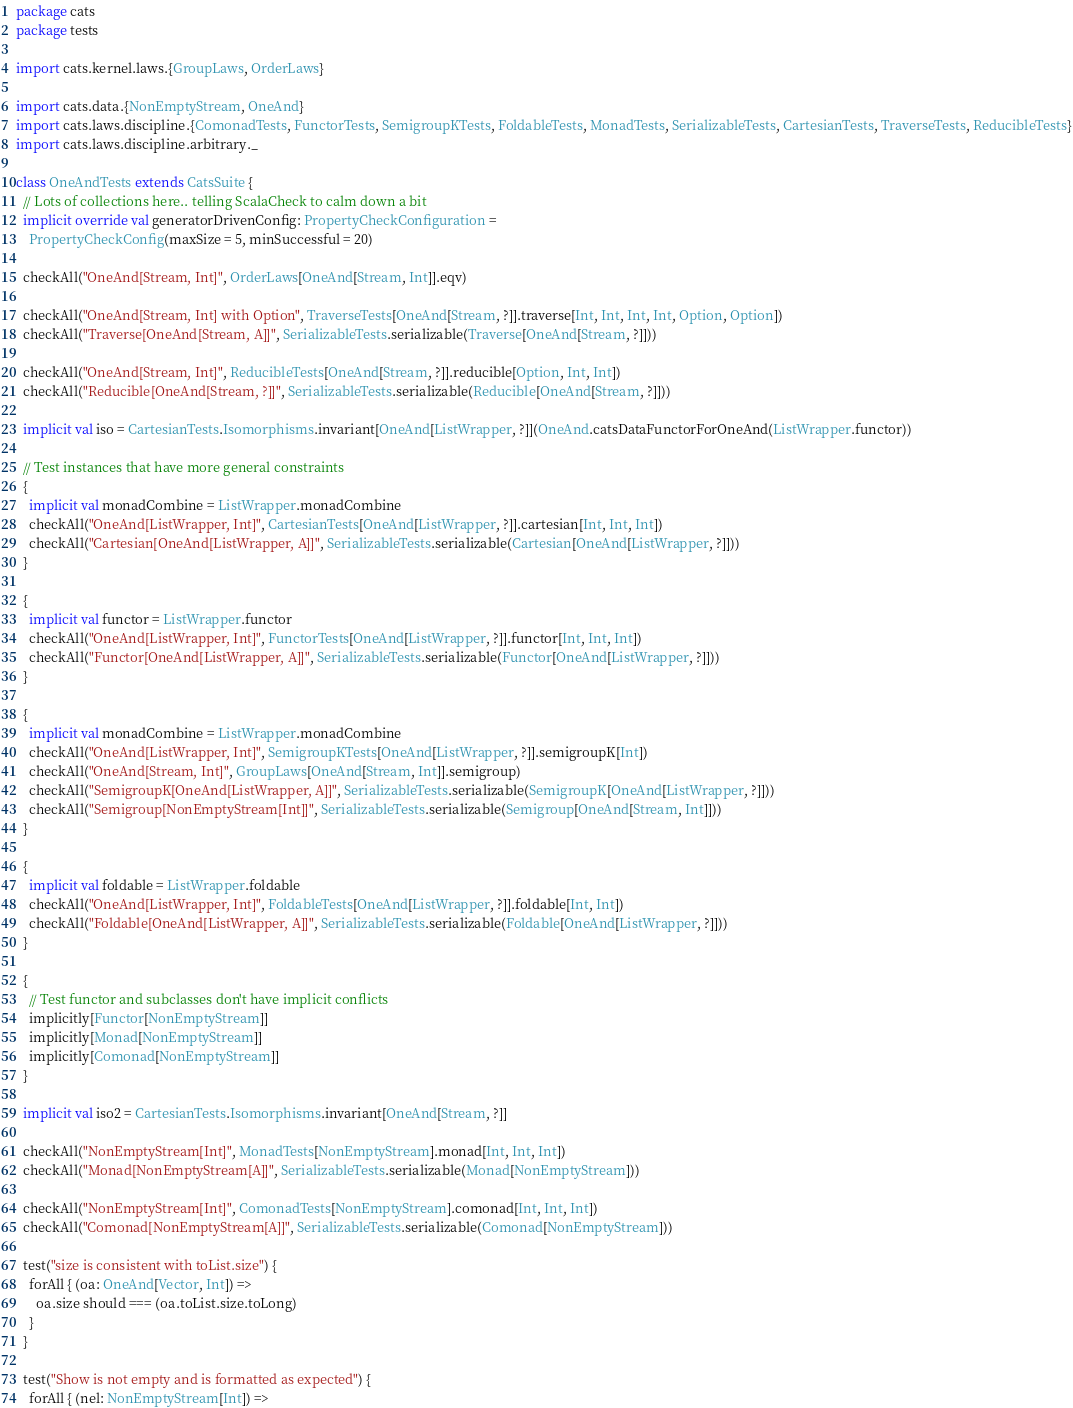Convert code to text. <code><loc_0><loc_0><loc_500><loc_500><_Scala_>package cats
package tests

import cats.kernel.laws.{GroupLaws, OrderLaws}

import cats.data.{NonEmptyStream, OneAnd}
import cats.laws.discipline.{ComonadTests, FunctorTests, SemigroupKTests, FoldableTests, MonadTests, SerializableTests, CartesianTests, TraverseTests, ReducibleTests}
import cats.laws.discipline.arbitrary._

class OneAndTests extends CatsSuite {
  // Lots of collections here.. telling ScalaCheck to calm down a bit
  implicit override val generatorDrivenConfig: PropertyCheckConfiguration =
    PropertyCheckConfig(maxSize = 5, minSuccessful = 20)

  checkAll("OneAnd[Stream, Int]", OrderLaws[OneAnd[Stream, Int]].eqv)

  checkAll("OneAnd[Stream, Int] with Option", TraverseTests[OneAnd[Stream, ?]].traverse[Int, Int, Int, Int, Option, Option])
  checkAll("Traverse[OneAnd[Stream, A]]", SerializableTests.serializable(Traverse[OneAnd[Stream, ?]]))

  checkAll("OneAnd[Stream, Int]", ReducibleTests[OneAnd[Stream, ?]].reducible[Option, Int, Int])
  checkAll("Reducible[OneAnd[Stream, ?]]", SerializableTests.serializable(Reducible[OneAnd[Stream, ?]]))

  implicit val iso = CartesianTests.Isomorphisms.invariant[OneAnd[ListWrapper, ?]](OneAnd.catsDataFunctorForOneAnd(ListWrapper.functor))

  // Test instances that have more general constraints
  {
    implicit val monadCombine = ListWrapper.monadCombine
    checkAll("OneAnd[ListWrapper, Int]", CartesianTests[OneAnd[ListWrapper, ?]].cartesian[Int, Int, Int])
    checkAll("Cartesian[OneAnd[ListWrapper, A]]", SerializableTests.serializable(Cartesian[OneAnd[ListWrapper, ?]]))
  }

  {
    implicit val functor = ListWrapper.functor
    checkAll("OneAnd[ListWrapper, Int]", FunctorTests[OneAnd[ListWrapper, ?]].functor[Int, Int, Int])
    checkAll("Functor[OneAnd[ListWrapper, A]]", SerializableTests.serializable(Functor[OneAnd[ListWrapper, ?]]))
  }

  {
    implicit val monadCombine = ListWrapper.monadCombine
    checkAll("OneAnd[ListWrapper, Int]", SemigroupKTests[OneAnd[ListWrapper, ?]].semigroupK[Int])
    checkAll("OneAnd[Stream, Int]", GroupLaws[OneAnd[Stream, Int]].semigroup)
    checkAll("SemigroupK[OneAnd[ListWrapper, A]]", SerializableTests.serializable(SemigroupK[OneAnd[ListWrapper, ?]]))
    checkAll("Semigroup[NonEmptyStream[Int]]", SerializableTests.serializable(Semigroup[OneAnd[Stream, Int]]))
  }

  {
    implicit val foldable = ListWrapper.foldable
    checkAll("OneAnd[ListWrapper, Int]", FoldableTests[OneAnd[ListWrapper, ?]].foldable[Int, Int])
    checkAll("Foldable[OneAnd[ListWrapper, A]]", SerializableTests.serializable(Foldable[OneAnd[ListWrapper, ?]]))
  }

  {
    // Test functor and subclasses don't have implicit conflicts
    implicitly[Functor[NonEmptyStream]]
    implicitly[Monad[NonEmptyStream]]
    implicitly[Comonad[NonEmptyStream]]
  }

  implicit val iso2 = CartesianTests.Isomorphisms.invariant[OneAnd[Stream, ?]]

  checkAll("NonEmptyStream[Int]", MonadTests[NonEmptyStream].monad[Int, Int, Int])
  checkAll("Monad[NonEmptyStream[A]]", SerializableTests.serializable(Monad[NonEmptyStream]))

  checkAll("NonEmptyStream[Int]", ComonadTests[NonEmptyStream].comonad[Int, Int, Int])
  checkAll("Comonad[NonEmptyStream[A]]", SerializableTests.serializable(Comonad[NonEmptyStream]))

  test("size is consistent with toList.size") {
    forAll { (oa: OneAnd[Vector, Int]) =>
      oa.size should === (oa.toList.size.toLong)
    }
  }

  test("Show is not empty and is formatted as expected") {
    forAll { (nel: NonEmptyStream[Int]) =></code> 